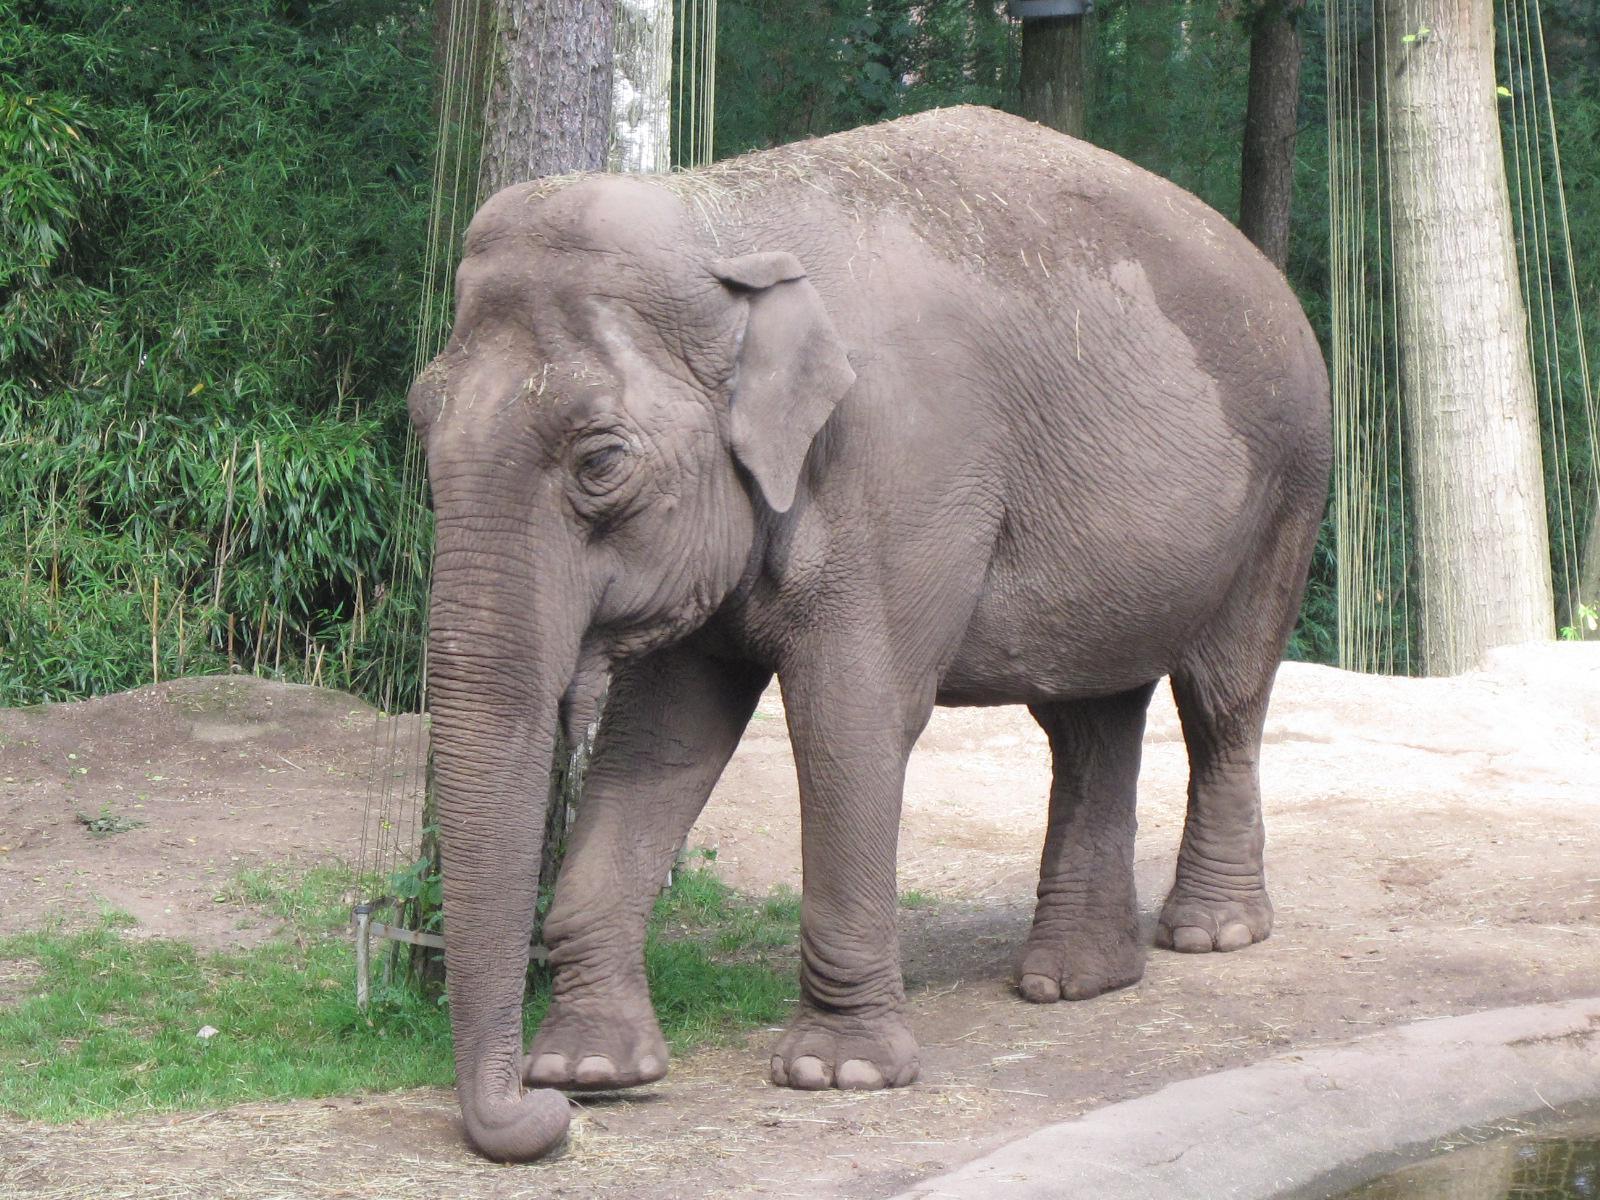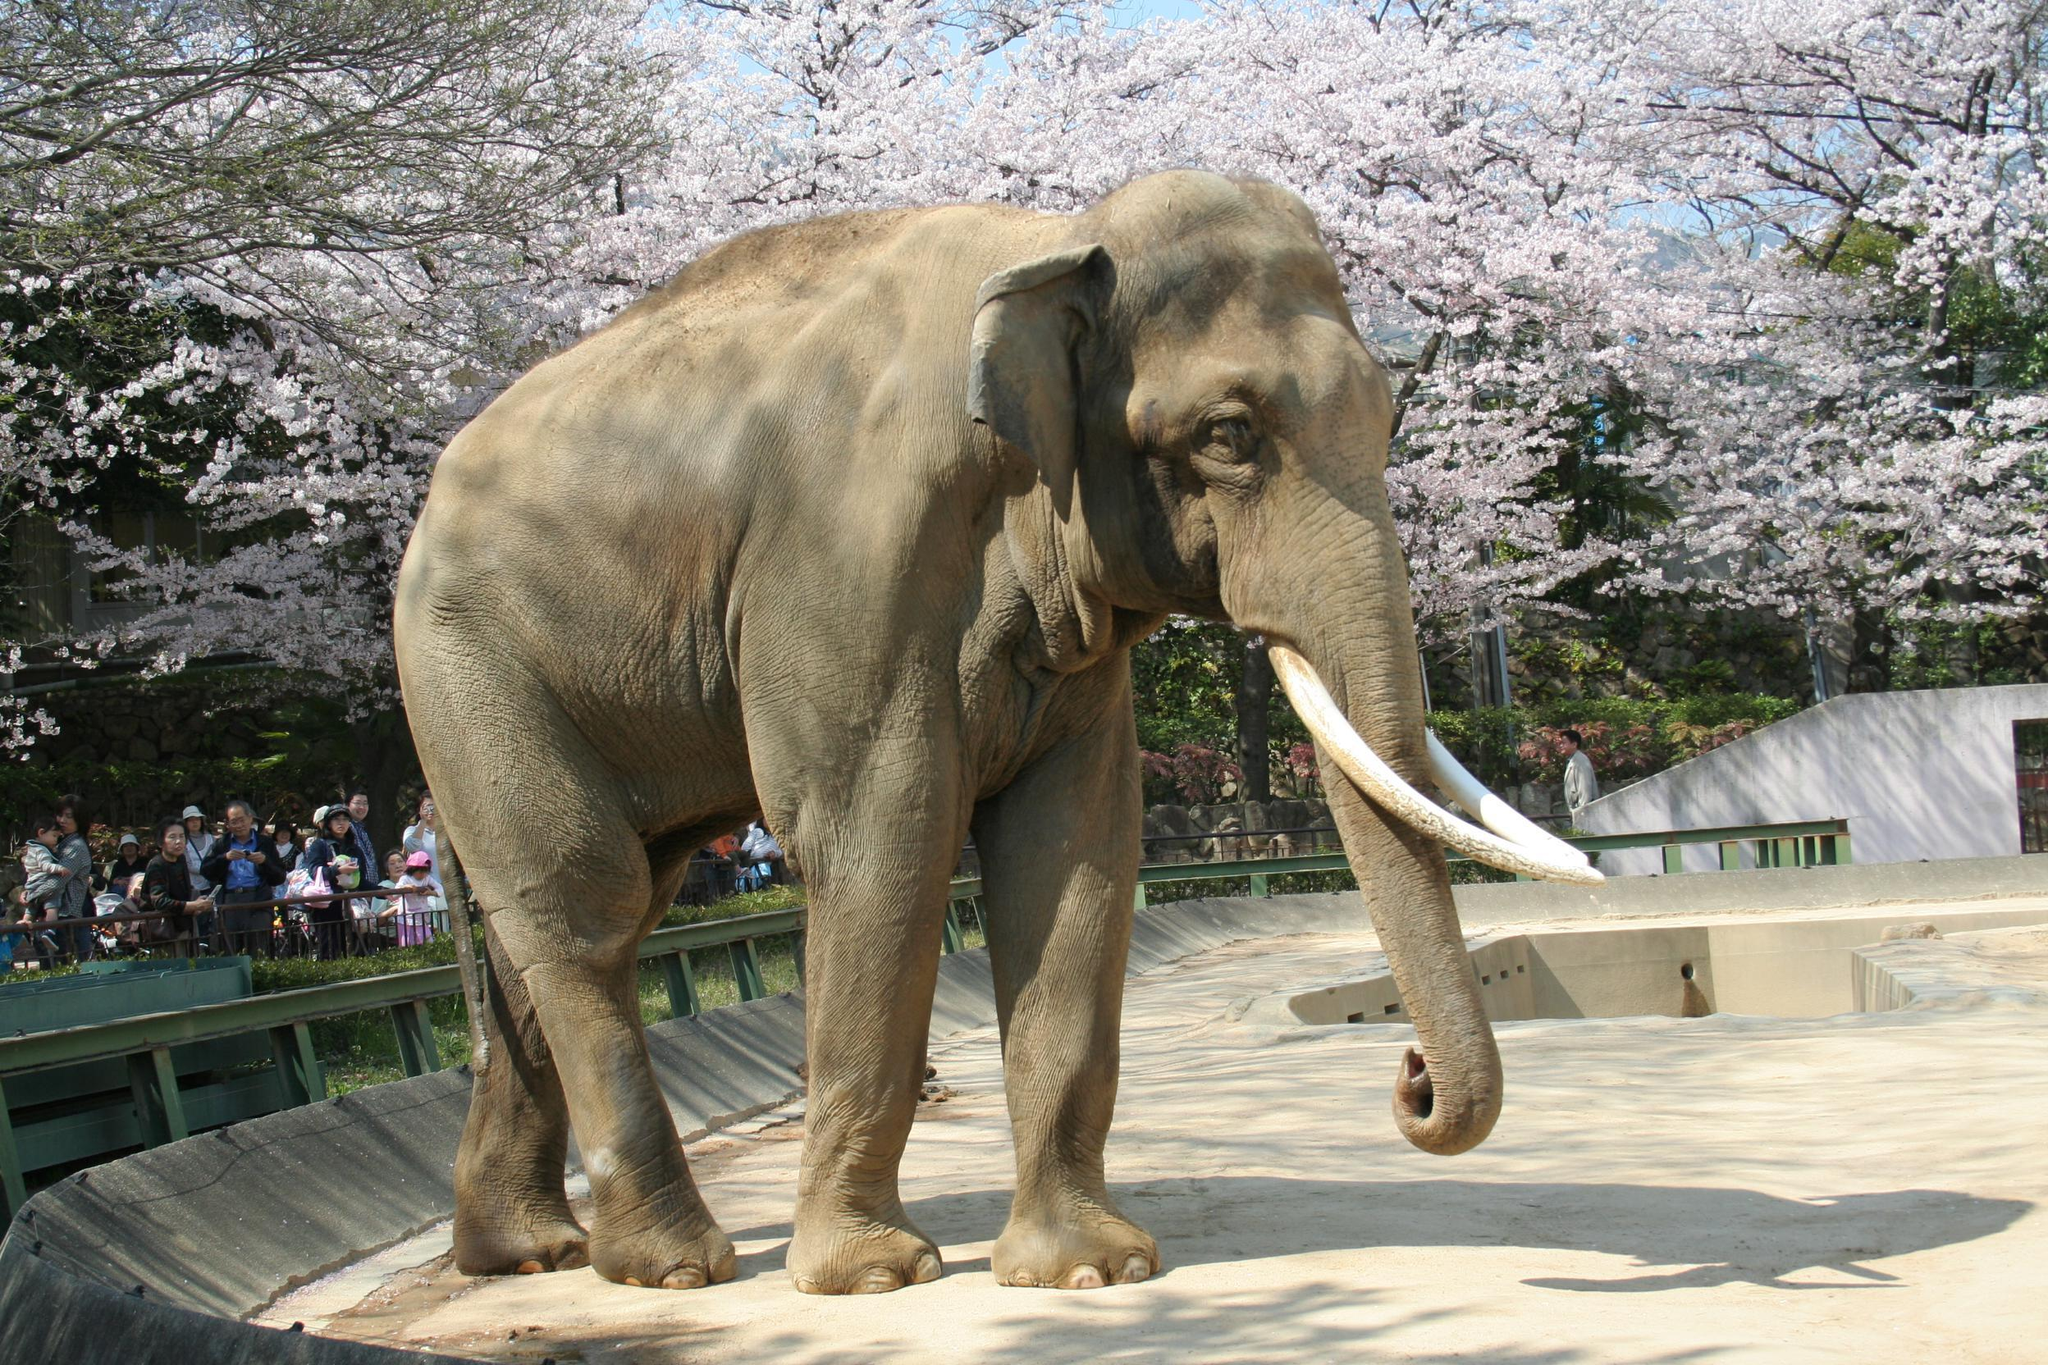The first image is the image on the left, the second image is the image on the right. Analyze the images presented: Is the assertion "There's at least three elephants." valid? Answer yes or no. No. The first image is the image on the left, the second image is the image on the right. Evaluate the accuracy of this statement regarding the images: "There are the same number of elephants in both images.". Is it true? Answer yes or no. Yes. 